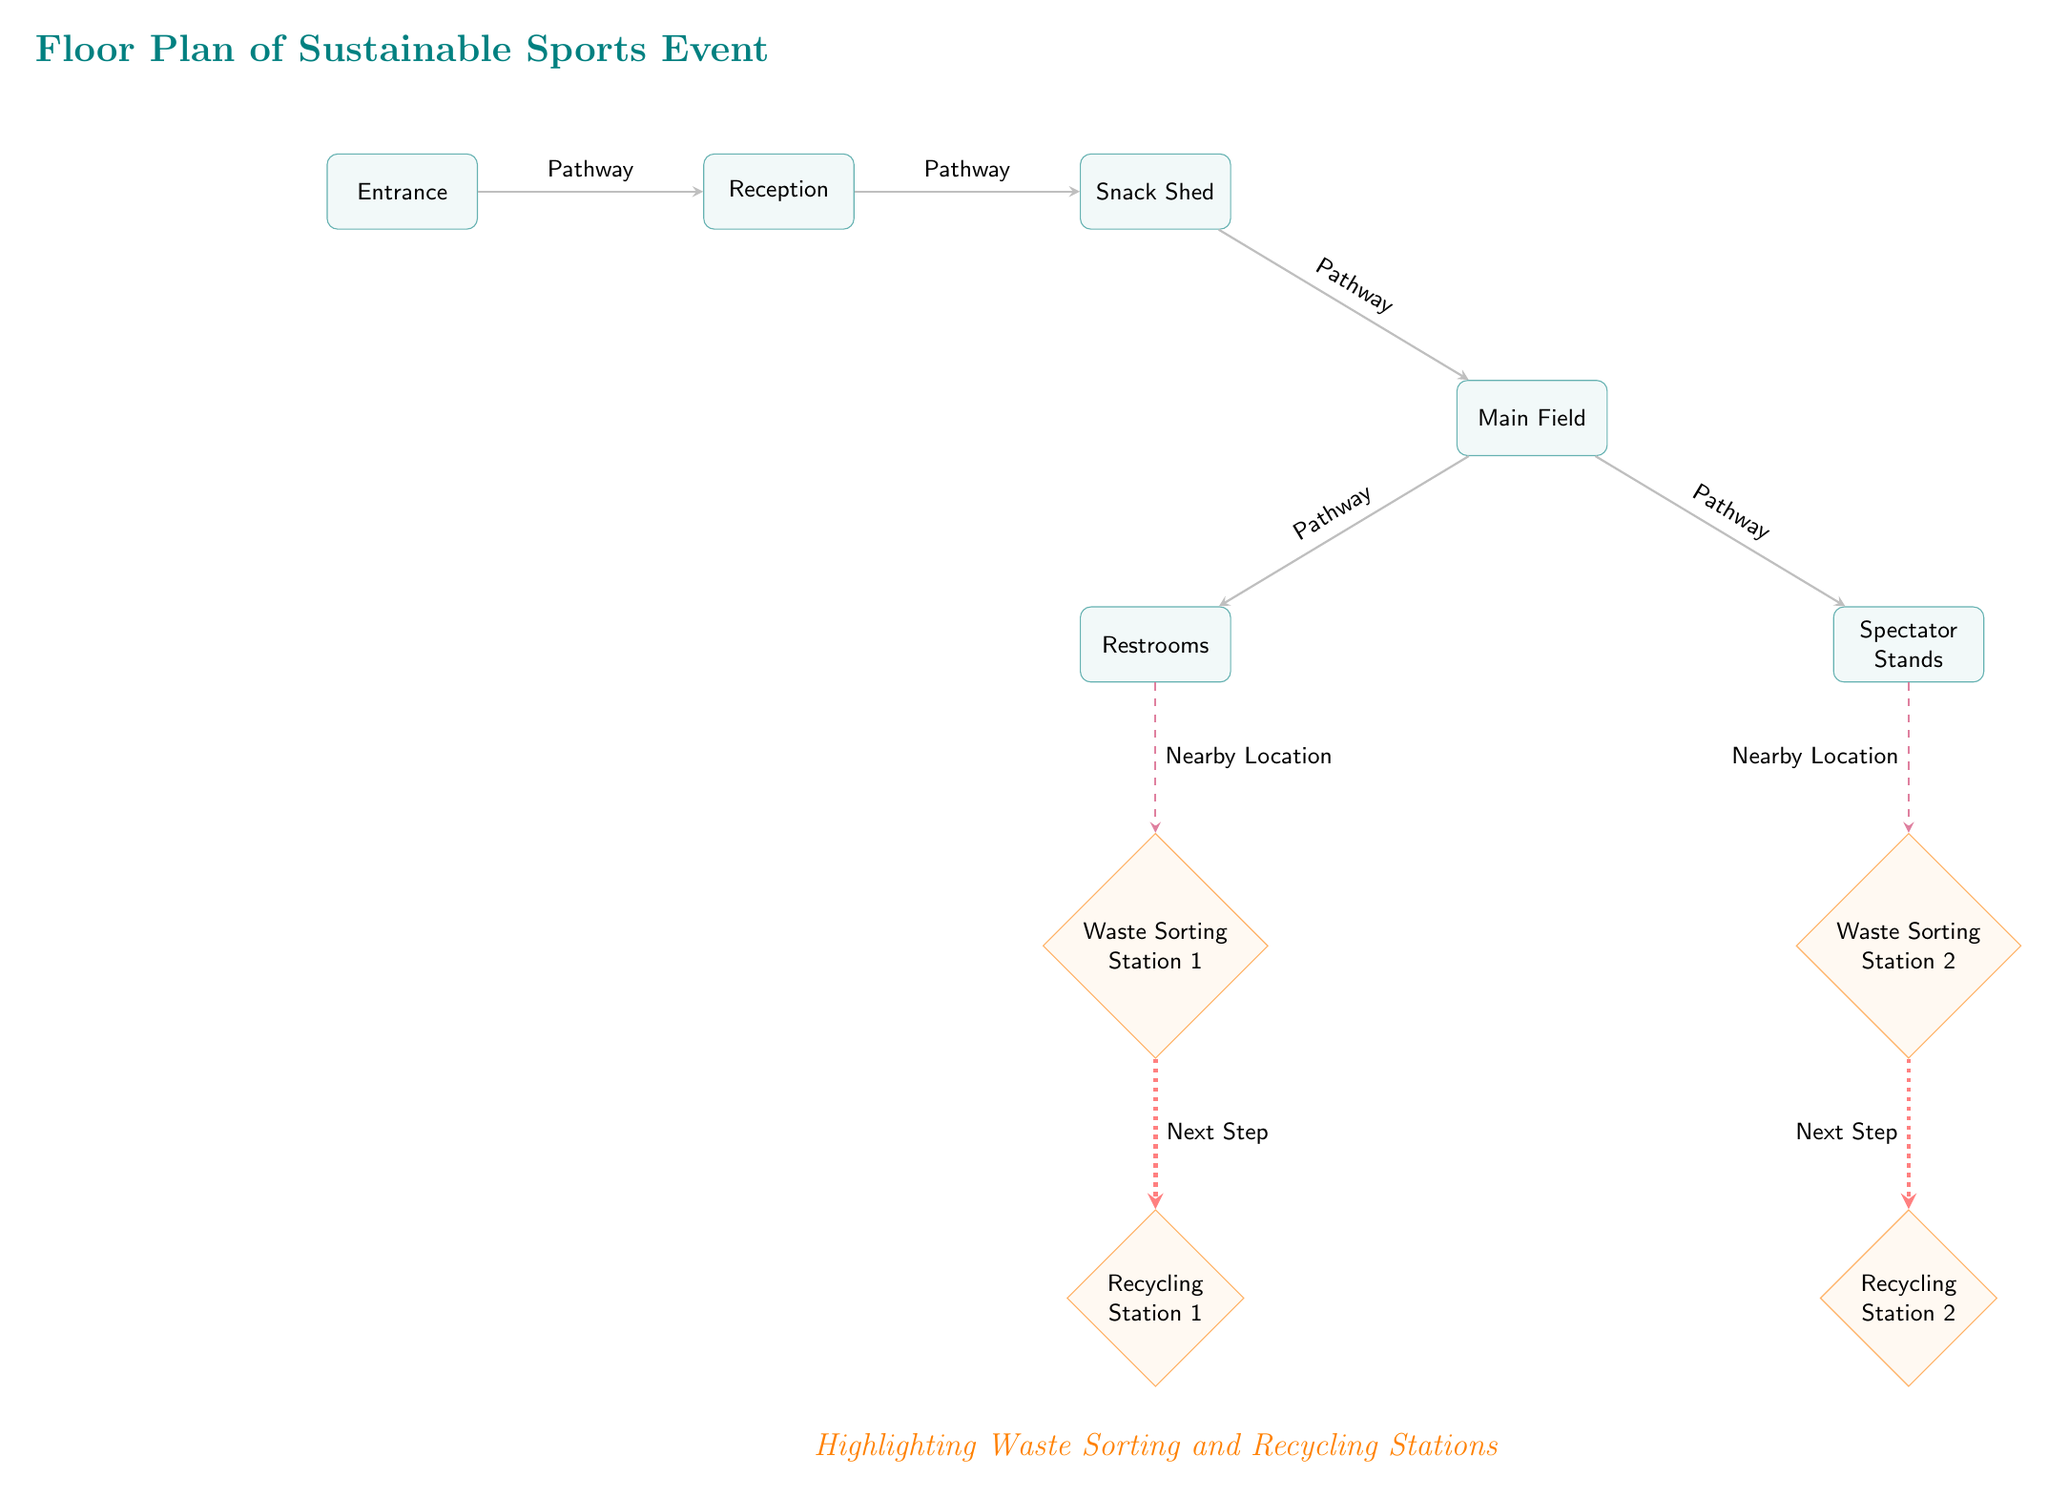What is located at the entrance? The diagram indicates that the location at the entrance is "Entrance".
Answer: Entrance How many waste sorting stations are there? The diagram shows two waste sorting stations labeled as Waste Sorting Station 1 and Waste Sorting Station 2.
Answer: 2 What is the relationship between Main Field and Spectator Stands? The diagram shows a pathway connecting the Main Field to the Spectator Stands, indicating they are adjacent locations.
Answer: Pathway Which station is nearest to the restrooms? The diagram indicates Waste Sorting Station 1 is located nearby the restrooms.
Answer: Waste Sorting Station 1 What is the next step after Waste Sorting Station 2? According to the diagram, the next step after Waste Sorting Station 2 is Recycling Station 2.
Answer: Recycling Station 2 List all locations connected directly to the Snack Shed. The diagram displays pathways leading from the Snack Shed to the Reception and the Main Field.
Answer: Reception, Main Field Which two stations are located under the waste sorting stations? The diagram shows Recycling Station 1 is below Waste Sorting Station 1 and Recycling Station 2 is below Waste Sorting Station 2.
Answer: Recycling Station 1, Recycling Station 2 Where is Waste Sorting Station 1 positioned relative to the Main Field? The diagram illustrates that Waste Sorting Station 1 is located below the Restrooms, which is below the Main Field.
Answer: Below What color represents the waste sorting stations? The diagram indicates that the waste sorting stations are represented in orange color.
Answer: Orange 